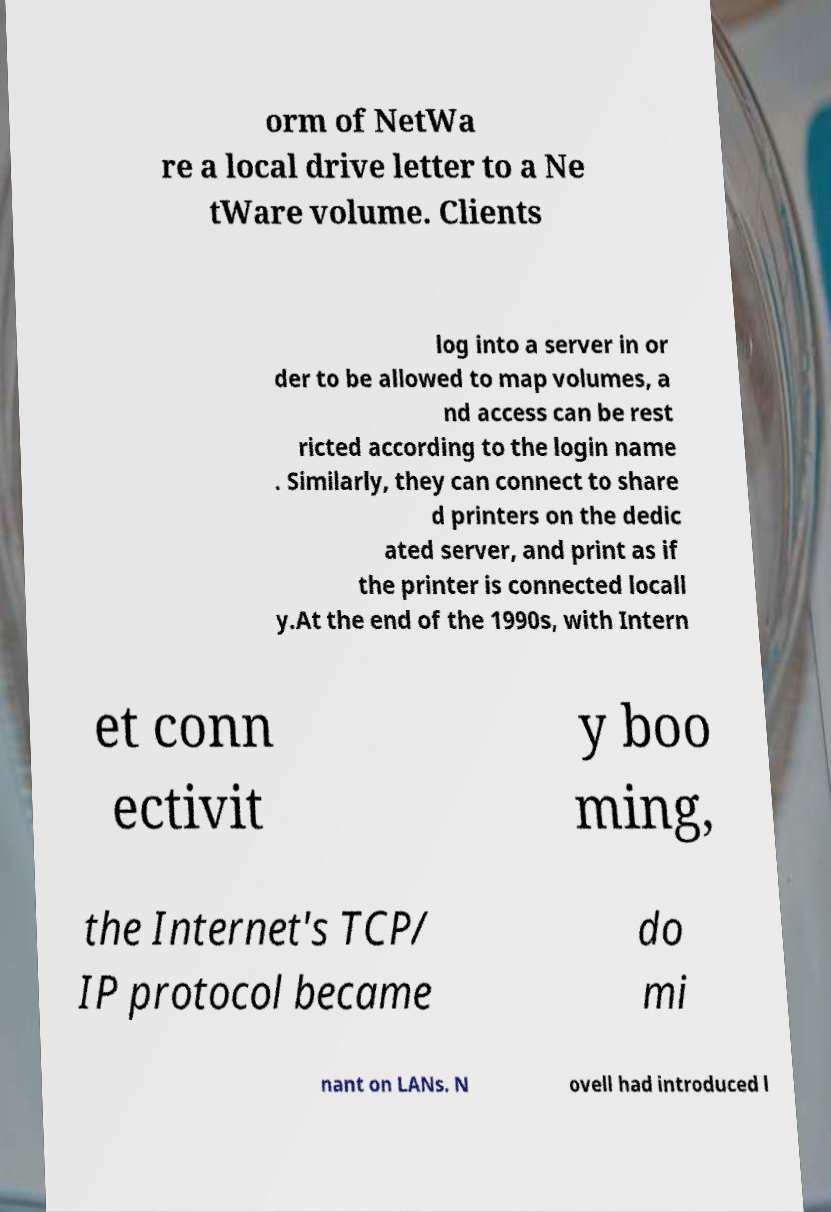Can you read and provide the text displayed in the image?This photo seems to have some interesting text. Can you extract and type it out for me? orm of NetWa re a local drive letter to a Ne tWare volume. Clients log into a server in or der to be allowed to map volumes, a nd access can be rest ricted according to the login name . Similarly, they can connect to share d printers on the dedic ated server, and print as if the printer is connected locall y.At the end of the 1990s, with Intern et conn ectivit y boo ming, the Internet's TCP/ IP protocol became do mi nant on LANs. N ovell had introduced l 